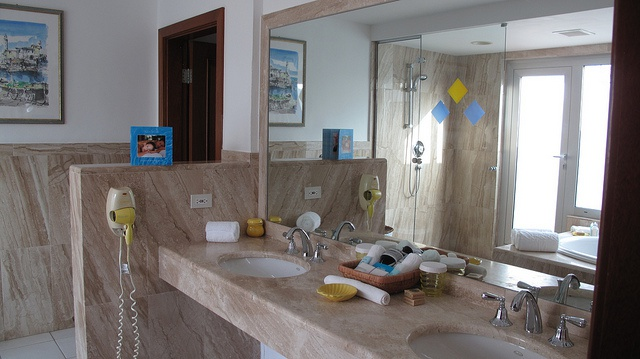Describe the objects in this image and their specific colors. I can see sink in gray tones, sink in gray tones, and hair drier in gray and olive tones in this image. 